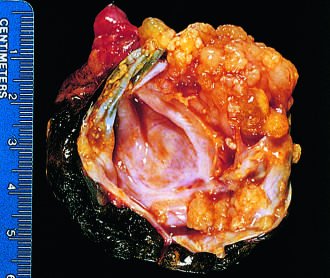s the moderate-power view of the plaque opened to display a cyst cavity lined by delicate papillary tumor growths?
Answer the question using a single word or phrase. No 